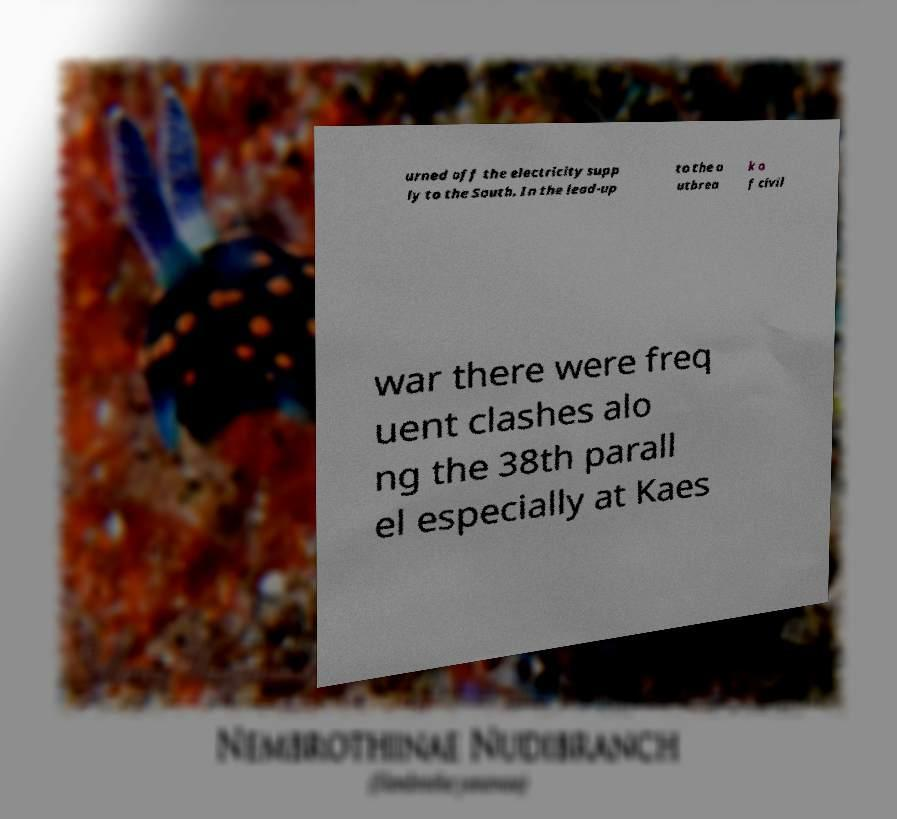For documentation purposes, I need the text within this image transcribed. Could you provide that? urned off the electricity supp ly to the South. In the lead-up to the o utbrea k o f civil war there were freq uent clashes alo ng the 38th parall el especially at Kaes 